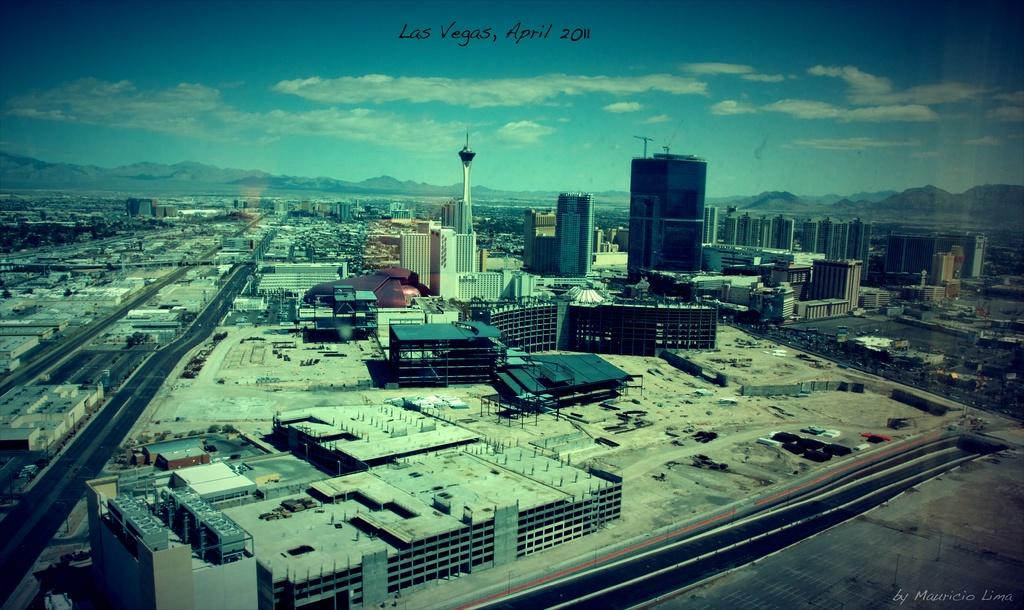What type of view is shown in the image? The image is a top view of a city. What can be seen on the ground in the image? There are roads visible in the image. What structures are present in the image? There are buildings and a tower in the image. What natural feature is visible in the image? There are mountains in the image. What is visible at the top of the image? The sky is visible at the top of the image. What is written in the center at the top of the image? There is some text in the center at the top of the image. What type of popcorn is being served in the image? There is no popcorn present in the image. How many celery sticks are visible in the image? There is no celery in the image. What statement is being made by the image? The image itself does not make a statement; it is a visual representation of a city. 